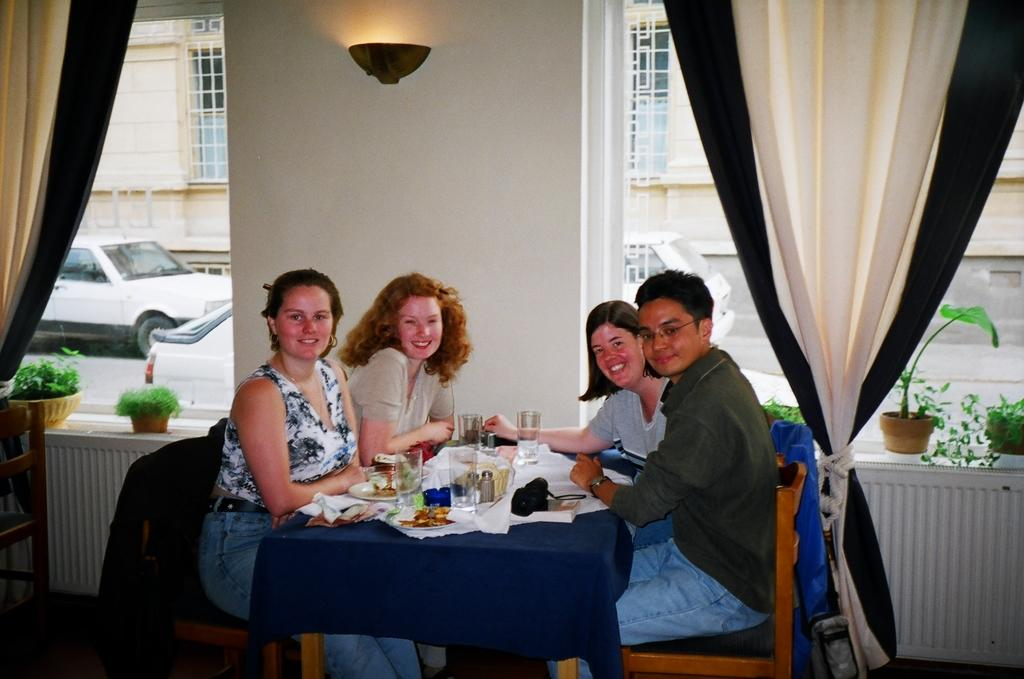What are the people in the image doing? The people in the image are sitting on chairs. What is present on the table in the image? There is a camera and a glass on the table in the image. What else can be seen on the table? There are food items on a plate on the table. What type of cloth is draped over the camera in the image? There is no cloth draped over the camera in the image; it is visible without any covering. 